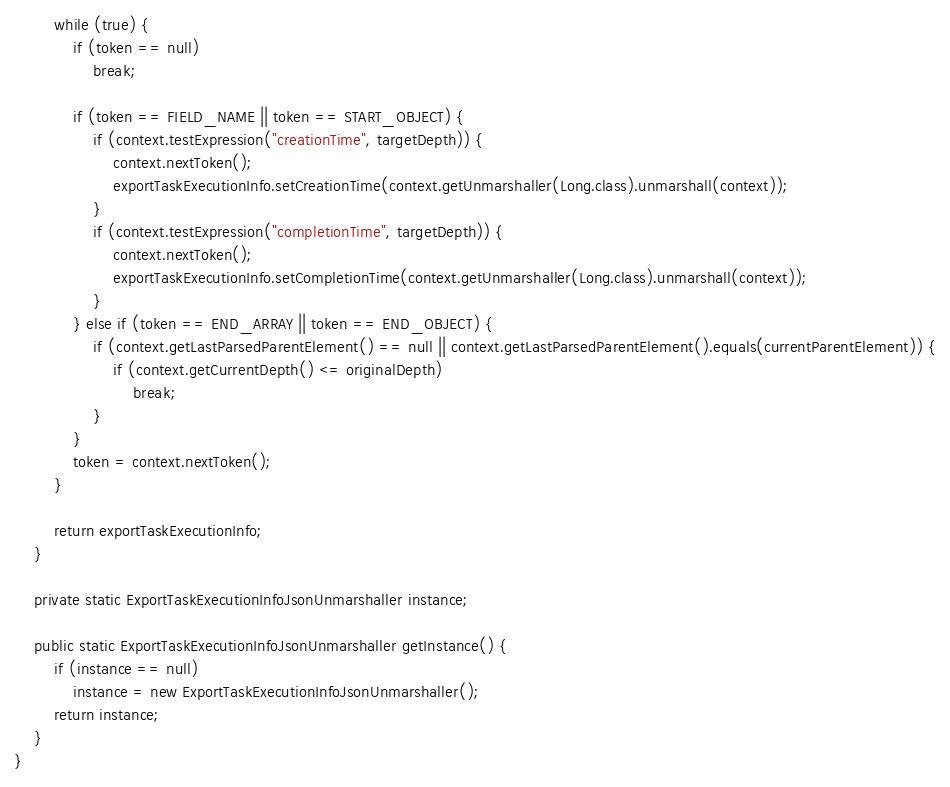Convert code to text. <code><loc_0><loc_0><loc_500><loc_500><_Java_>
        while (true) {
            if (token == null)
                break;

            if (token == FIELD_NAME || token == START_OBJECT) {
                if (context.testExpression("creationTime", targetDepth)) {
                    context.nextToken();
                    exportTaskExecutionInfo.setCreationTime(context.getUnmarshaller(Long.class).unmarshall(context));
                }
                if (context.testExpression("completionTime", targetDepth)) {
                    context.nextToken();
                    exportTaskExecutionInfo.setCompletionTime(context.getUnmarshaller(Long.class).unmarshall(context));
                }
            } else if (token == END_ARRAY || token == END_OBJECT) {
                if (context.getLastParsedParentElement() == null || context.getLastParsedParentElement().equals(currentParentElement)) {
                    if (context.getCurrentDepth() <= originalDepth)
                        break;
                }
            }
            token = context.nextToken();
        }

        return exportTaskExecutionInfo;
    }

    private static ExportTaskExecutionInfoJsonUnmarshaller instance;

    public static ExportTaskExecutionInfoJsonUnmarshaller getInstance() {
        if (instance == null)
            instance = new ExportTaskExecutionInfoJsonUnmarshaller();
        return instance;
    }
}
</code> 